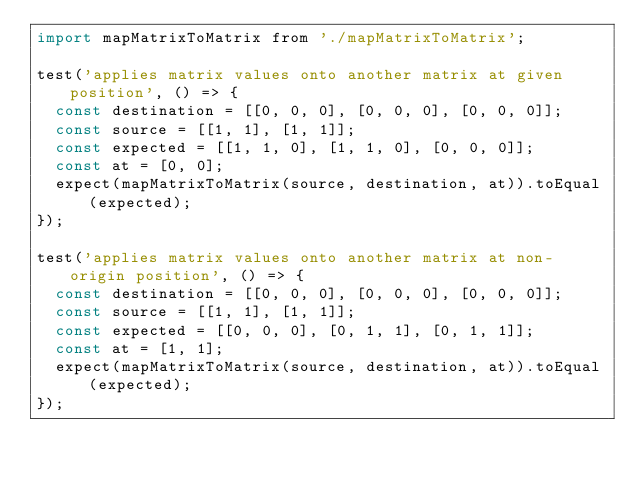<code> <loc_0><loc_0><loc_500><loc_500><_JavaScript_>import mapMatrixToMatrix from './mapMatrixToMatrix';

test('applies matrix values onto another matrix at given position', () => {
  const destination = [[0, 0, 0], [0, 0, 0], [0, 0, 0]];
  const source = [[1, 1], [1, 1]];
  const expected = [[1, 1, 0], [1, 1, 0], [0, 0, 0]];
  const at = [0, 0];
  expect(mapMatrixToMatrix(source, destination, at)).toEqual(expected);
});

test('applies matrix values onto another matrix at non-origin position', () => {
  const destination = [[0, 0, 0], [0, 0, 0], [0, 0, 0]];
  const source = [[1, 1], [1, 1]];
  const expected = [[0, 0, 0], [0, 1, 1], [0, 1, 1]];
  const at = [1, 1];
  expect(mapMatrixToMatrix(source, destination, at)).toEqual(expected);
});
</code> 